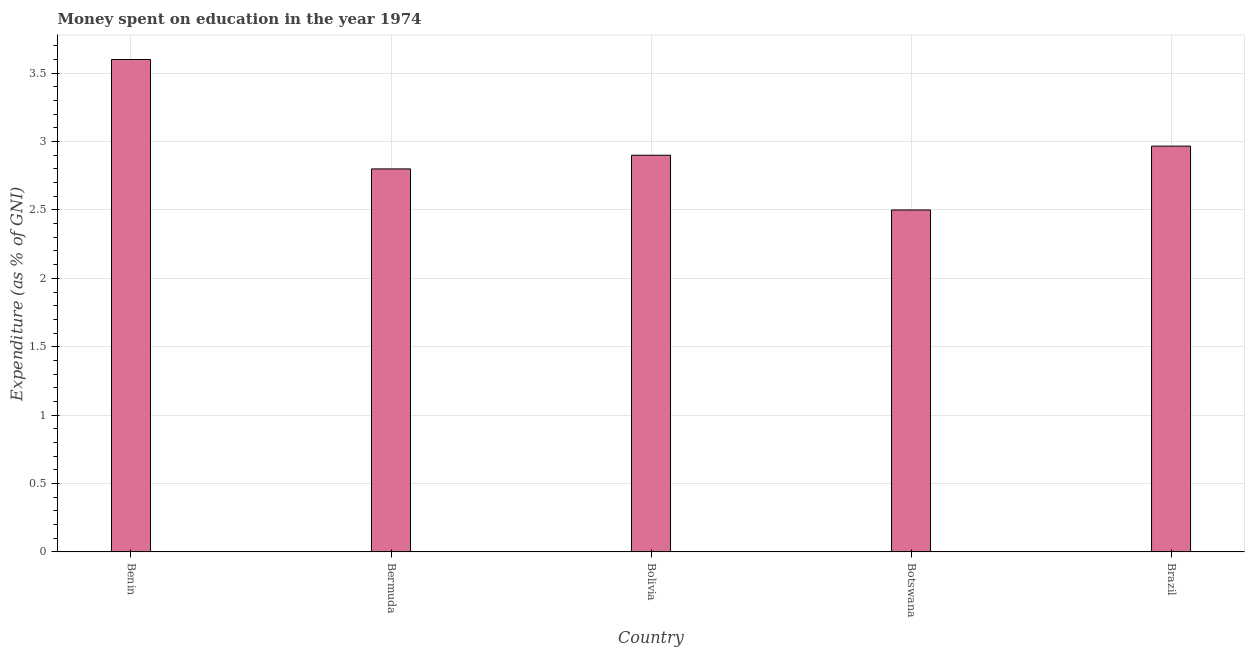Does the graph contain any zero values?
Your answer should be very brief. No. What is the title of the graph?
Provide a short and direct response. Money spent on education in the year 1974. What is the label or title of the X-axis?
Ensure brevity in your answer.  Country. What is the label or title of the Y-axis?
Your answer should be very brief. Expenditure (as % of GNI). What is the expenditure on education in Brazil?
Ensure brevity in your answer.  2.97. In which country was the expenditure on education maximum?
Your response must be concise. Benin. In which country was the expenditure on education minimum?
Offer a terse response. Botswana. What is the sum of the expenditure on education?
Provide a short and direct response. 14.77. What is the difference between the expenditure on education in Benin and Bermuda?
Your answer should be compact. 0.8. What is the average expenditure on education per country?
Keep it short and to the point. 2.95. What is the median expenditure on education?
Offer a very short reply. 2.9. What is the ratio of the expenditure on education in Bermuda to that in Brazil?
Provide a short and direct response. 0.94. Is the expenditure on education in Bolivia less than that in Botswana?
Give a very brief answer. No. Is the difference between the expenditure on education in Benin and Botswana greater than the difference between any two countries?
Your response must be concise. Yes. What is the difference between the highest and the second highest expenditure on education?
Your response must be concise. 0.63. Is the sum of the expenditure on education in Benin and Brazil greater than the maximum expenditure on education across all countries?
Your answer should be very brief. Yes. What is the difference between two consecutive major ticks on the Y-axis?
Your answer should be compact. 0.5. What is the Expenditure (as % of GNI) in Benin?
Your answer should be very brief. 3.6. What is the Expenditure (as % of GNI) of Bermuda?
Provide a short and direct response. 2.8. What is the Expenditure (as % of GNI) of Botswana?
Make the answer very short. 2.5. What is the Expenditure (as % of GNI) of Brazil?
Offer a terse response. 2.97. What is the difference between the Expenditure (as % of GNI) in Benin and Bolivia?
Offer a very short reply. 0.7. What is the difference between the Expenditure (as % of GNI) in Benin and Botswana?
Provide a succinct answer. 1.1. What is the difference between the Expenditure (as % of GNI) in Benin and Brazil?
Keep it short and to the point. 0.63. What is the difference between the Expenditure (as % of GNI) in Bermuda and Bolivia?
Offer a terse response. -0.1. What is the difference between the Expenditure (as % of GNI) in Bermuda and Brazil?
Provide a short and direct response. -0.17. What is the difference between the Expenditure (as % of GNI) in Bolivia and Brazil?
Give a very brief answer. -0.07. What is the difference between the Expenditure (as % of GNI) in Botswana and Brazil?
Your answer should be compact. -0.47. What is the ratio of the Expenditure (as % of GNI) in Benin to that in Bermuda?
Provide a succinct answer. 1.29. What is the ratio of the Expenditure (as % of GNI) in Benin to that in Bolivia?
Give a very brief answer. 1.24. What is the ratio of the Expenditure (as % of GNI) in Benin to that in Botswana?
Provide a short and direct response. 1.44. What is the ratio of the Expenditure (as % of GNI) in Benin to that in Brazil?
Provide a short and direct response. 1.21. What is the ratio of the Expenditure (as % of GNI) in Bermuda to that in Botswana?
Provide a succinct answer. 1.12. What is the ratio of the Expenditure (as % of GNI) in Bermuda to that in Brazil?
Keep it short and to the point. 0.94. What is the ratio of the Expenditure (as % of GNI) in Bolivia to that in Botswana?
Your answer should be compact. 1.16. What is the ratio of the Expenditure (as % of GNI) in Botswana to that in Brazil?
Make the answer very short. 0.84. 